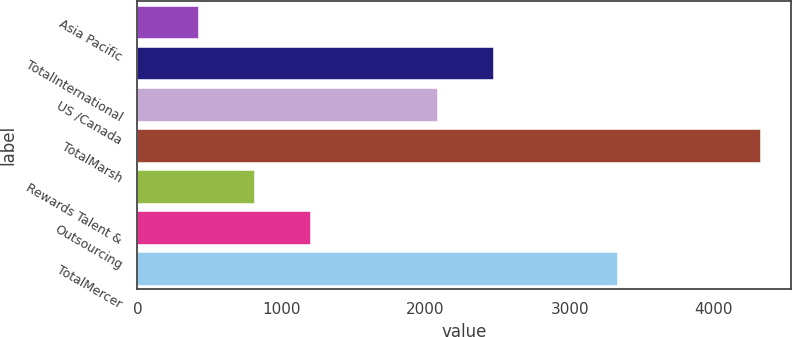Convert chart to OTSL. <chart><loc_0><loc_0><loc_500><loc_500><bar_chart><fcel>Asia Pacific<fcel>TotalInternational<fcel>US /Canada<fcel>TotalMarsh<fcel>Rewards Talent &<fcel>Outsourcing<fcel>TotalMercer<nl><fcel>419<fcel>2468<fcel>2078<fcel>4319<fcel>809<fcel>1199<fcel>3327<nl></chart> 